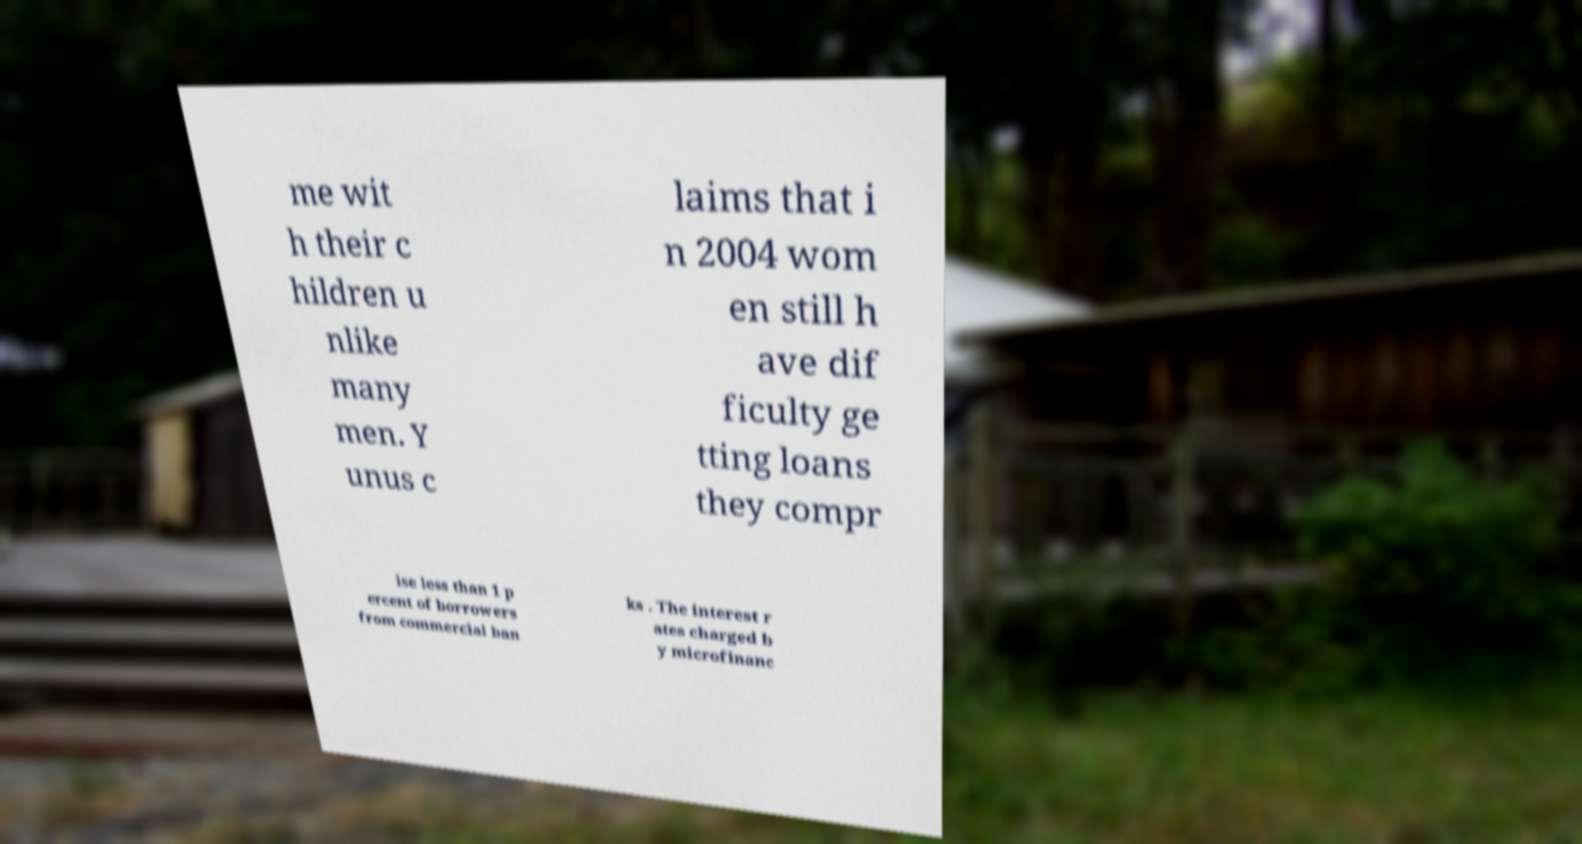Can you accurately transcribe the text from the provided image for me? me wit h their c hildren u nlike many men. Y unus c laims that i n 2004 wom en still h ave dif ficulty ge tting loans they compr ise less than 1 p ercent of borrowers from commercial ban ks . The interest r ates charged b y microfinanc 